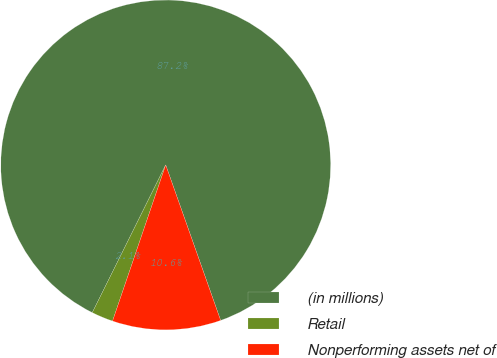Convert chart to OTSL. <chart><loc_0><loc_0><loc_500><loc_500><pie_chart><fcel>(in millions)<fcel>Retail<fcel>Nonperforming assets net of<nl><fcel>87.25%<fcel>2.12%<fcel>10.63%<nl></chart> 